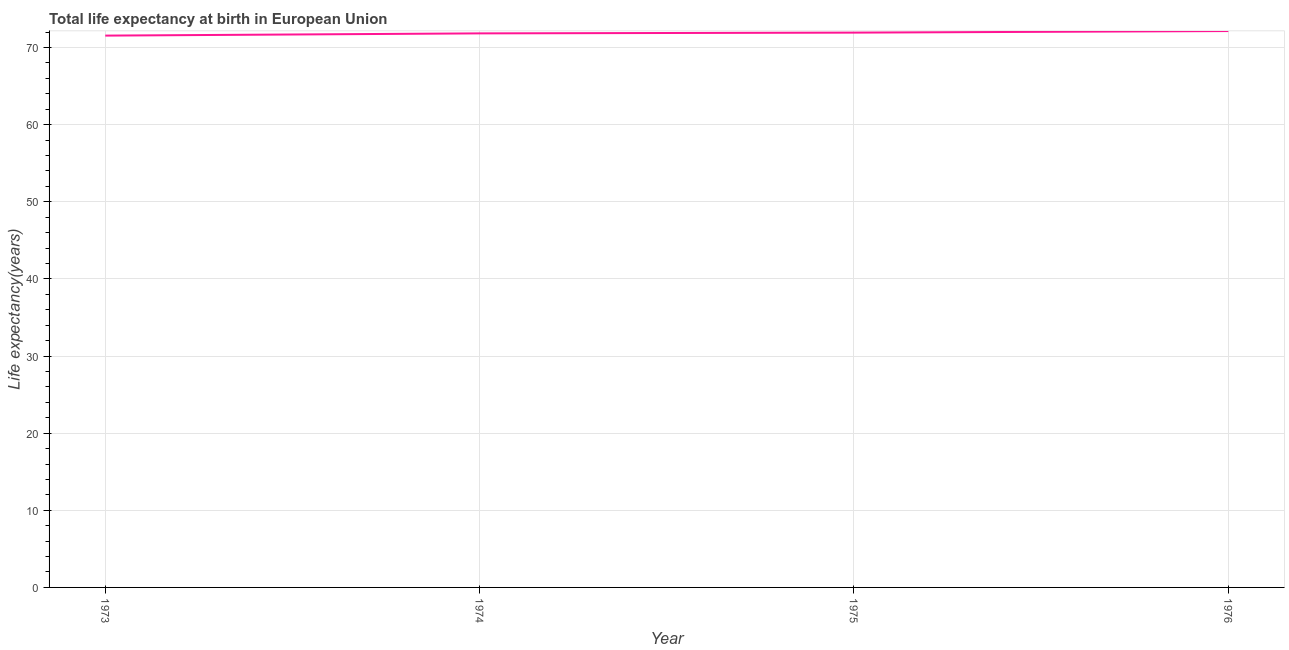What is the life expectancy at birth in 1974?
Offer a very short reply. 71.82. Across all years, what is the maximum life expectancy at birth?
Make the answer very short. 72.12. Across all years, what is the minimum life expectancy at birth?
Your response must be concise. 71.53. In which year was the life expectancy at birth maximum?
Provide a short and direct response. 1976. In which year was the life expectancy at birth minimum?
Give a very brief answer. 1973. What is the sum of the life expectancy at birth?
Your response must be concise. 287.4. What is the difference between the life expectancy at birth in 1974 and 1975?
Provide a succinct answer. -0.1. What is the average life expectancy at birth per year?
Make the answer very short. 71.85. What is the median life expectancy at birth?
Offer a very short reply. 71.87. In how many years, is the life expectancy at birth greater than 8 years?
Your answer should be compact. 4. What is the ratio of the life expectancy at birth in 1973 to that in 1976?
Provide a succinct answer. 0.99. Is the life expectancy at birth in 1975 less than that in 1976?
Your response must be concise. Yes. What is the difference between the highest and the second highest life expectancy at birth?
Your answer should be compact. 0.2. What is the difference between the highest and the lowest life expectancy at birth?
Provide a short and direct response. 0.59. In how many years, is the life expectancy at birth greater than the average life expectancy at birth taken over all years?
Offer a very short reply. 2. How many lines are there?
Your answer should be very brief. 1. How many years are there in the graph?
Provide a succinct answer. 4. Are the values on the major ticks of Y-axis written in scientific E-notation?
Offer a very short reply. No. What is the title of the graph?
Offer a terse response. Total life expectancy at birth in European Union. What is the label or title of the Y-axis?
Your response must be concise. Life expectancy(years). What is the Life expectancy(years) in 1973?
Provide a succinct answer. 71.53. What is the Life expectancy(years) in 1974?
Your response must be concise. 71.82. What is the Life expectancy(years) in 1975?
Offer a terse response. 71.92. What is the Life expectancy(years) in 1976?
Your answer should be compact. 72.12. What is the difference between the Life expectancy(years) in 1973 and 1974?
Offer a very short reply. -0.29. What is the difference between the Life expectancy(years) in 1973 and 1975?
Keep it short and to the point. -0.39. What is the difference between the Life expectancy(years) in 1973 and 1976?
Give a very brief answer. -0.59. What is the difference between the Life expectancy(years) in 1974 and 1975?
Provide a succinct answer. -0.1. What is the difference between the Life expectancy(years) in 1974 and 1976?
Provide a succinct answer. -0.3. What is the difference between the Life expectancy(years) in 1975 and 1976?
Make the answer very short. -0.2. What is the ratio of the Life expectancy(years) in 1973 to that in 1975?
Provide a short and direct response. 0.99. What is the ratio of the Life expectancy(years) in 1973 to that in 1976?
Ensure brevity in your answer.  0.99. What is the ratio of the Life expectancy(years) in 1974 to that in 1975?
Your answer should be very brief. 1. What is the ratio of the Life expectancy(years) in 1974 to that in 1976?
Offer a very short reply. 1. What is the ratio of the Life expectancy(years) in 1975 to that in 1976?
Your answer should be compact. 1. 